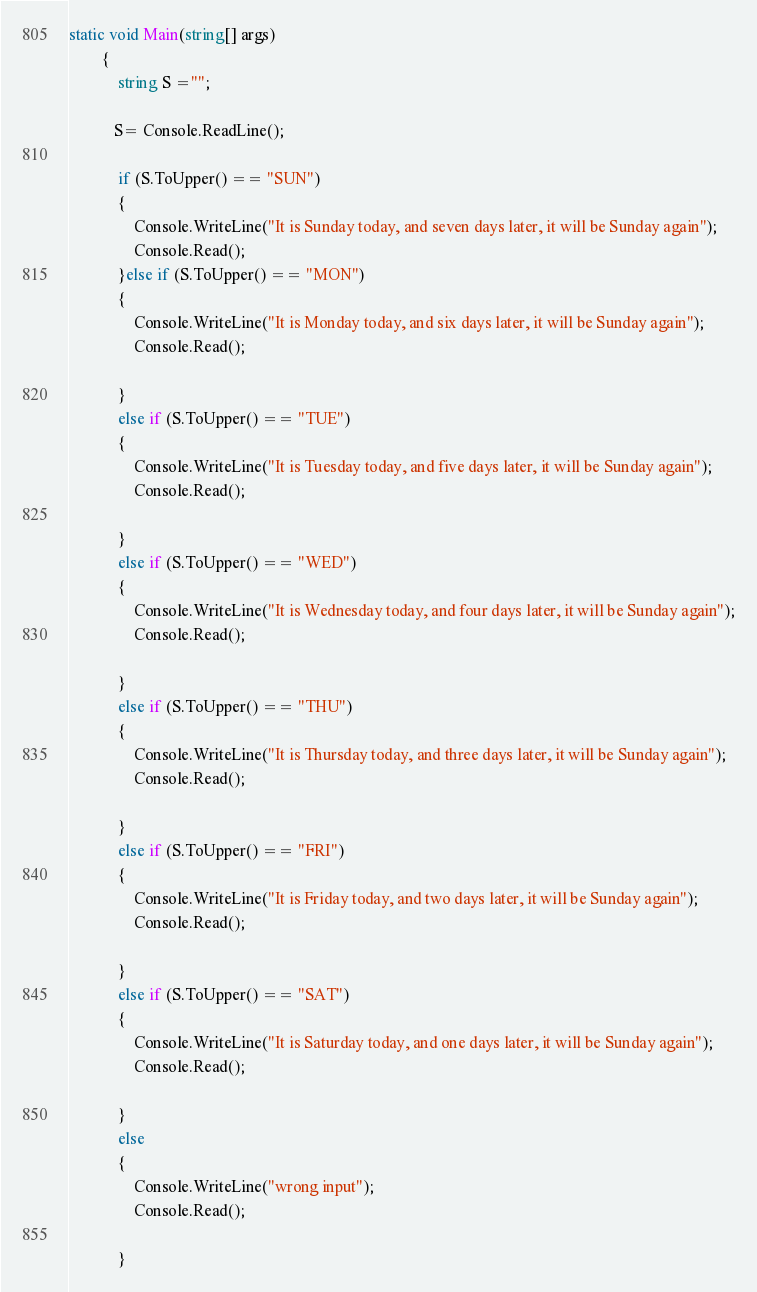Convert code to text. <code><loc_0><loc_0><loc_500><loc_500><_C#_>static void Main(string[] args)
        {
            string S ="";

           S= Console.ReadLine();
         
            if (S.ToUpper() == "SUN")
            {
                Console.WriteLine("It is Sunday today, and seven days later, it will be Sunday again");
                Console.Read();
            }else if (S.ToUpper() == "MON")
            {
                Console.WriteLine("It is Monday today, and six days later, it will be Sunday again");
                Console.Read();

            }
            else if (S.ToUpper() == "TUE")
            {
                Console.WriteLine("It is Tuesday today, and five days later, it will be Sunday again");
                Console.Read();

            }
            else if (S.ToUpper() == "WED")
            {
                Console.WriteLine("It is Wednesday today, and four days later, it will be Sunday again");
                Console.Read();

            }
            else if (S.ToUpper() == "THU")
            {
                Console.WriteLine("It is Thursday today, and three days later, it will be Sunday again");
                Console.Read();

            }
            else if (S.ToUpper() == "FRI")
            {
                Console.WriteLine("It is Friday today, and two days later, it will be Sunday again");
                Console.Read();

            }
            else if (S.ToUpper() == "SAT")
            {
                Console.WriteLine("It is Saturday today, and one days later, it will be Sunday again");
                Console.Read();

            }
            else
            {
                Console.WriteLine("wrong input");
                Console.Read();

            }</code> 